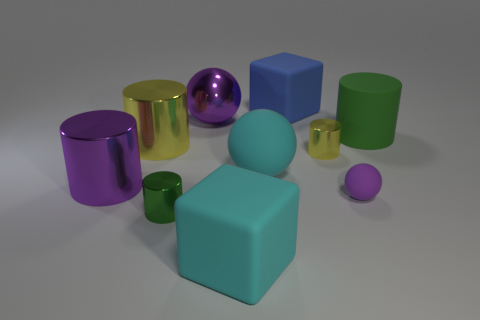What time of day does the lighting suggest in the scene? The lighting in the scene does not strongly suggest a particular time of day as it appears to be artificial and studio-like, with even lighting that minimizes shadows and provides good visibility of all objects. 